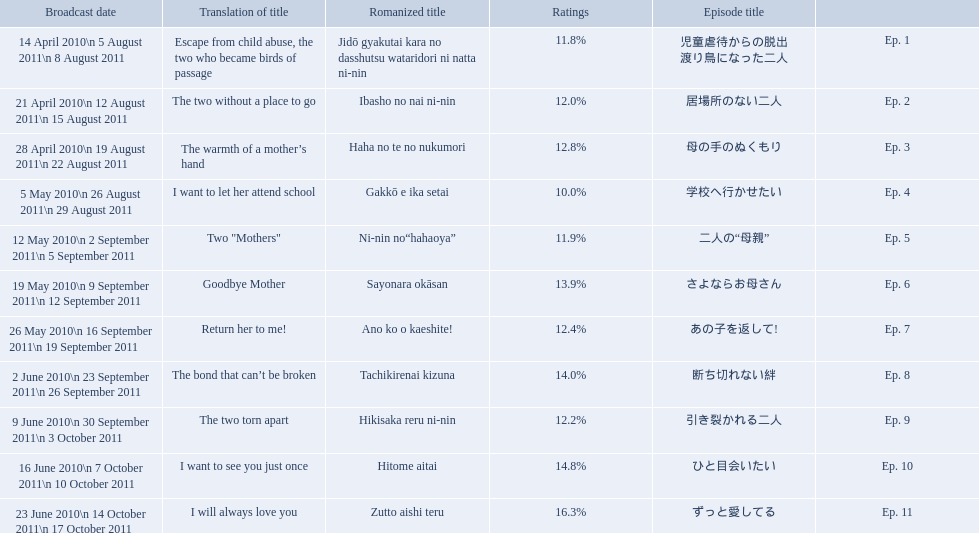How many total episodes are there? Ep. 1, Ep. 2, Ep. 3, Ep. 4, Ep. 5, Ep. 6, Ep. 7, Ep. 8, Ep. 9, Ep. 10, Ep. 11. Of those episodes, which one has the title of the bond that can't be broken? Ep. 8. What was the ratings percentage for that episode? 14.0%. Could you help me parse every detail presented in this table? {'header': ['Broadcast date', 'Translation of title', 'Romanized title', 'Ratings', 'Episode title', ''], 'rows': [['14 April 2010\\n 5 August 2011\\n 8 August 2011', 'Escape from child abuse, the two who became birds of passage', 'Jidō gyakutai kara no dasshutsu wataridori ni natta ni-nin', '11.8%', '児童虐待からの脱出 渡り鳥になった二人', 'Ep. 1'], ['21 April 2010\\n 12 August 2011\\n 15 August 2011', 'The two without a place to go', 'Ibasho no nai ni-nin', '12.0%', '居場所のない二人', 'Ep. 2'], ['28 April 2010\\n 19 August 2011\\n 22 August 2011', 'The warmth of a mother’s hand', 'Haha no te no nukumori', '12.8%', '母の手のぬくもり', 'Ep. 3'], ['5 May 2010\\n 26 August 2011\\n 29 August 2011', 'I want to let her attend school', 'Gakkō e ika setai', '10.0%', '学校へ行かせたい', 'Ep. 4'], ['12 May 2010\\n 2 September 2011\\n 5 September 2011', 'Two "Mothers"', 'Ni-nin no“hahaoya”', '11.9%', '二人の“母親”', 'Ep. 5'], ['19 May 2010\\n 9 September 2011\\n 12 September 2011', 'Goodbye Mother', 'Sayonara okāsan', '13.9%', 'さよならお母さん', 'Ep. 6'], ['26 May 2010\\n 16 September 2011\\n 19 September 2011', 'Return her to me!', 'Ano ko o kaeshite!', '12.4%', 'あの子を返して!', 'Ep. 7'], ['2 June 2010\\n 23 September 2011\\n 26 September 2011', 'The bond that can’t be broken', 'Tachikirenai kizuna', '14.0%', '断ち切れない絆', 'Ep. 8'], ['9 June 2010\\n 30 September 2011\\n 3 October 2011', 'The two torn apart', 'Hikisaka reru ni-nin', '12.2%', '引き裂かれる二人', 'Ep. 9'], ['16 June 2010\\n 7 October 2011\\n 10 October 2011', 'I want to see you just once', 'Hitome aitai', '14.8%', 'ひと目会いたい', 'Ep. 10'], ['23 June 2010\\n 14 October 2011\\n 17 October 2011', 'I will always love you', 'Zutto aishi teru', '16.3%', 'ずっと愛してる', 'Ep. 11']]} Which episode was titled the two without a place to go? Ep. 2. What was the title of ep. 3? The warmth of a mother’s hand. Which episode had a rating of 10.0%? Ep. 4. 